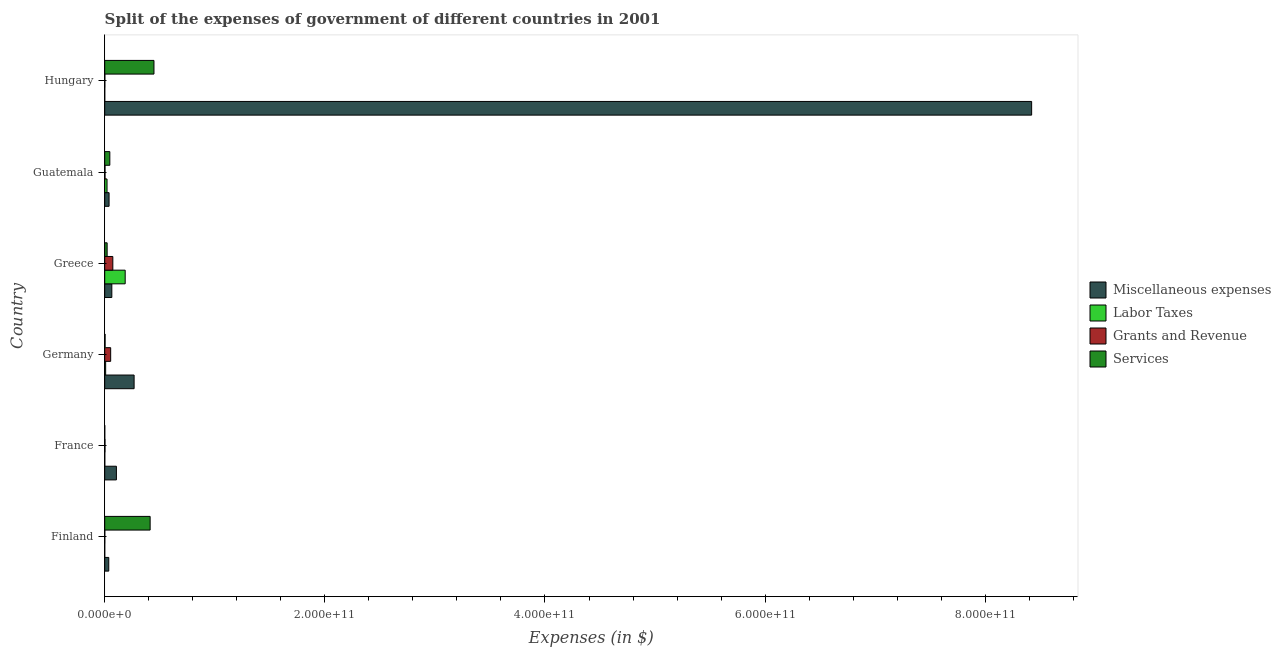How many different coloured bars are there?
Keep it short and to the point. 4. How many groups of bars are there?
Your answer should be very brief. 6. Are the number of bars per tick equal to the number of legend labels?
Provide a succinct answer. Yes. Are the number of bars on each tick of the Y-axis equal?
Offer a terse response. Yes. In how many cases, is the number of bars for a given country not equal to the number of legend labels?
Your response must be concise. 0. What is the amount spent on grants and revenue in Germany?
Provide a short and direct response. 5.41e+09. Across all countries, what is the maximum amount spent on miscellaneous expenses?
Make the answer very short. 8.42e+11. Across all countries, what is the minimum amount spent on grants and revenue?
Make the answer very short. 6.53e+07. In which country was the amount spent on miscellaneous expenses maximum?
Provide a short and direct response. Hungary. In which country was the amount spent on services minimum?
Your answer should be compact. France. What is the total amount spent on services in the graph?
Your response must be concise. 9.32e+1. What is the difference between the amount spent on miscellaneous expenses in Finland and that in France?
Ensure brevity in your answer.  -6.94e+09. What is the difference between the amount spent on services in Finland and the amount spent on grants and revenue in Germany?
Your response must be concise. 3.59e+1. What is the average amount spent on miscellaneous expenses per country?
Keep it short and to the point. 1.49e+11. What is the difference between the amount spent on labor taxes and amount spent on grants and revenue in Finland?
Provide a short and direct response. -6.29e+07. What is the ratio of the amount spent on grants and revenue in Guatemala to that in Hungary?
Keep it short and to the point. 2.46. Is the amount spent on services in Germany less than that in Greece?
Provide a short and direct response. Yes. Is the difference between the amount spent on labor taxes in France and Hungary greater than the difference between the amount spent on grants and revenue in France and Hungary?
Provide a short and direct response. No. What is the difference between the highest and the second highest amount spent on labor taxes?
Provide a succinct answer. 1.65e+1. What is the difference between the highest and the lowest amount spent on labor taxes?
Provide a succinct answer. 1.86e+1. Is the sum of the amount spent on miscellaneous expenses in Finland and France greater than the maximum amount spent on labor taxes across all countries?
Your answer should be compact. No. What does the 3rd bar from the top in Guatemala represents?
Your answer should be compact. Labor Taxes. What does the 3rd bar from the bottom in Guatemala represents?
Your answer should be very brief. Grants and Revenue. Is it the case that in every country, the sum of the amount spent on miscellaneous expenses and amount spent on labor taxes is greater than the amount spent on grants and revenue?
Your answer should be very brief. Yes. How many bars are there?
Keep it short and to the point. 24. What is the difference between two consecutive major ticks on the X-axis?
Ensure brevity in your answer.  2.00e+11. Does the graph contain grids?
Your response must be concise. No. How many legend labels are there?
Your response must be concise. 4. What is the title of the graph?
Your response must be concise. Split of the expenses of government of different countries in 2001. Does "Luxembourg" appear as one of the legend labels in the graph?
Your answer should be compact. No. What is the label or title of the X-axis?
Offer a terse response. Expenses (in $). What is the label or title of the Y-axis?
Provide a succinct answer. Country. What is the Expenses (in $) in Miscellaneous expenses in Finland?
Your response must be concise. 3.68e+09. What is the Expenses (in $) in Labor Taxes in Finland?
Provide a short and direct response. 2.40e+06. What is the Expenses (in $) of Grants and Revenue in Finland?
Your answer should be very brief. 6.53e+07. What is the Expenses (in $) in Services in Finland?
Provide a succinct answer. 4.13e+1. What is the Expenses (in $) of Miscellaneous expenses in France?
Ensure brevity in your answer.  1.06e+1. What is the Expenses (in $) of Labor Taxes in France?
Make the answer very short. 5.79e+07. What is the Expenses (in $) in Grants and Revenue in France?
Provide a short and direct response. 2.59e+08. What is the Expenses (in $) in Services in France?
Your answer should be compact. 3.23e+07. What is the Expenses (in $) in Miscellaneous expenses in Germany?
Make the answer very short. 2.67e+1. What is the Expenses (in $) of Labor Taxes in Germany?
Offer a terse response. 8.46e+08. What is the Expenses (in $) of Grants and Revenue in Germany?
Offer a terse response. 5.41e+09. What is the Expenses (in $) in Services in Germany?
Your answer should be compact. 3.44e+08. What is the Expenses (in $) of Miscellaneous expenses in Greece?
Your answer should be compact. 6.46e+09. What is the Expenses (in $) in Labor Taxes in Greece?
Keep it short and to the point. 1.86e+1. What is the Expenses (in $) in Grants and Revenue in Greece?
Provide a short and direct response. 7.37e+09. What is the Expenses (in $) of Services in Greece?
Keep it short and to the point. 2.20e+09. What is the Expenses (in $) in Miscellaneous expenses in Guatemala?
Provide a succinct answer. 3.96e+09. What is the Expenses (in $) in Labor Taxes in Guatemala?
Ensure brevity in your answer.  2.10e+09. What is the Expenses (in $) in Grants and Revenue in Guatemala?
Offer a terse response. 2.69e+08. What is the Expenses (in $) in Services in Guatemala?
Provide a short and direct response. 4.64e+09. What is the Expenses (in $) of Miscellaneous expenses in Hungary?
Keep it short and to the point. 8.42e+11. What is the Expenses (in $) of Grants and Revenue in Hungary?
Your answer should be compact. 1.09e+08. What is the Expenses (in $) of Services in Hungary?
Provide a short and direct response. 4.47e+1. Across all countries, what is the maximum Expenses (in $) in Miscellaneous expenses?
Offer a very short reply. 8.42e+11. Across all countries, what is the maximum Expenses (in $) of Labor Taxes?
Give a very brief answer. 1.86e+1. Across all countries, what is the maximum Expenses (in $) of Grants and Revenue?
Give a very brief answer. 7.37e+09. Across all countries, what is the maximum Expenses (in $) in Services?
Ensure brevity in your answer.  4.47e+1. Across all countries, what is the minimum Expenses (in $) in Miscellaneous expenses?
Make the answer very short. 3.68e+09. Across all countries, what is the minimum Expenses (in $) of Labor Taxes?
Offer a very short reply. 2.40e+06. Across all countries, what is the minimum Expenses (in $) of Grants and Revenue?
Keep it short and to the point. 6.53e+07. Across all countries, what is the minimum Expenses (in $) of Services?
Give a very brief answer. 3.23e+07. What is the total Expenses (in $) of Miscellaneous expenses in the graph?
Provide a succinct answer. 8.94e+11. What is the total Expenses (in $) in Labor Taxes in the graph?
Ensure brevity in your answer.  2.16e+1. What is the total Expenses (in $) in Grants and Revenue in the graph?
Provide a succinct answer. 1.35e+1. What is the total Expenses (in $) in Services in the graph?
Your answer should be very brief. 9.32e+1. What is the difference between the Expenses (in $) in Miscellaneous expenses in Finland and that in France?
Make the answer very short. -6.94e+09. What is the difference between the Expenses (in $) of Labor Taxes in Finland and that in France?
Offer a very short reply. -5.55e+07. What is the difference between the Expenses (in $) in Grants and Revenue in Finland and that in France?
Give a very brief answer. -1.93e+08. What is the difference between the Expenses (in $) of Services in Finland and that in France?
Your answer should be very brief. 4.12e+1. What is the difference between the Expenses (in $) of Miscellaneous expenses in Finland and that in Germany?
Provide a short and direct response. -2.30e+1. What is the difference between the Expenses (in $) of Labor Taxes in Finland and that in Germany?
Your response must be concise. -8.44e+08. What is the difference between the Expenses (in $) of Grants and Revenue in Finland and that in Germany?
Keep it short and to the point. -5.34e+09. What is the difference between the Expenses (in $) of Services in Finland and that in Germany?
Keep it short and to the point. 4.09e+1. What is the difference between the Expenses (in $) of Miscellaneous expenses in Finland and that in Greece?
Offer a very short reply. -2.79e+09. What is the difference between the Expenses (in $) of Labor Taxes in Finland and that in Greece?
Offer a very short reply. -1.86e+1. What is the difference between the Expenses (in $) in Grants and Revenue in Finland and that in Greece?
Provide a succinct answer. -7.30e+09. What is the difference between the Expenses (in $) in Services in Finland and that in Greece?
Make the answer very short. 3.91e+1. What is the difference between the Expenses (in $) of Miscellaneous expenses in Finland and that in Guatemala?
Your response must be concise. -2.79e+08. What is the difference between the Expenses (in $) of Labor Taxes in Finland and that in Guatemala?
Ensure brevity in your answer.  -2.10e+09. What is the difference between the Expenses (in $) of Grants and Revenue in Finland and that in Guatemala?
Offer a terse response. -2.03e+08. What is the difference between the Expenses (in $) of Services in Finland and that in Guatemala?
Offer a terse response. 3.66e+1. What is the difference between the Expenses (in $) of Miscellaneous expenses in Finland and that in Hungary?
Ensure brevity in your answer.  -8.38e+11. What is the difference between the Expenses (in $) of Labor Taxes in Finland and that in Hungary?
Your answer should be compact. -7.60e+06. What is the difference between the Expenses (in $) in Grants and Revenue in Finland and that in Hungary?
Keep it short and to the point. -4.39e+07. What is the difference between the Expenses (in $) in Services in Finland and that in Hungary?
Provide a succinct answer. -3.47e+09. What is the difference between the Expenses (in $) of Miscellaneous expenses in France and that in Germany?
Your response must be concise. -1.61e+1. What is the difference between the Expenses (in $) of Labor Taxes in France and that in Germany?
Keep it short and to the point. -7.88e+08. What is the difference between the Expenses (in $) of Grants and Revenue in France and that in Germany?
Your answer should be compact. -5.15e+09. What is the difference between the Expenses (in $) of Services in France and that in Germany?
Offer a terse response. -3.12e+08. What is the difference between the Expenses (in $) in Miscellaneous expenses in France and that in Greece?
Provide a succinct answer. 4.16e+09. What is the difference between the Expenses (in $) of Labor Taxes in France and that in Greece?
Offer a very short reply. -1.85e+1. What is the difference between the Expenses (in $) of Grants and Revenue in France and that in Greece?
Provide a short and direct response. -7.11e+09. What is the difference between the Expenses (in $) of Services in France and that in Greece?
Make the answer very short. -2.16e+09. What is the difference between the Expenses (in $) in Miscellaneous expenses in France and that in Guatemala?
Your answer should be compact. 6.66e+09. What is the difference between the Expenses (in $) of Labor Taxes in France and that in Guatemala?
Your answer should be very brief. -2.05e+09. What is the difference between the Expenses (in $) in Grants and Revenue in France and that in Guatemala?
Your answer should be very brief. -9.90e+06. What is the difference between the Expenses (in $) in Services in France and that in Guatemala?
Make the answer very short. -4.61e+09. What is the difference between the Expenses (in $) of Miscellaneous expenses in France and that in Hungary?
Offer a very short reply. -8.32e+11. What is the difference between the Expenses (in $) in Labor Taxes in France and that in Hungary?
Give a very brief answer. 4.79e+07. What is the difference between the Expenses (in $) in Grants and Revenue in France and that in Hungary?
Ensure brevity in your answer.  1.50e+08. What is the difference between the Expenses (in $) in Services in France and that in Hungary?
Your answer should be compact. -4.47e+1. What is the difference between the Expenses (in $) in Miscellaneous expenses in Germany and that in Greece?
Make the answer very short. 2.02e+1. What is the difference between the Expenses (in $) in Labor Taxes in Germany and that in Greece?
Your response must be concise. -1.78e+1. What is the difference between the Expenses (in $) in Grants and Revenue in Germany and that in Greece?
Provide a short and direct response. -1.96e+09. What is the difference between the Expenses (in $) of Services in Germany and that in Greece?
Your answer should be compact. -1.85e+09. What is the difference between the Expenses (in $) of Miscellaneous expenses in Germany and that in Guatemala?
Make the answer very short. 2.27e+1. What is the difference between the Expenses (in $) in Labor Taxes in Germany and that in Guatemala?
Provide a short and direct response. -1.26e+09. What is the difference between the Expenses (in $) of Grants and Revenue in Germany and that in Guatemala?
Provide a short and direct response. 5.14e+09. What is the difference between the Expenses (in $) in Services in Germany and that in Guatemala?
Your response must be concise. -4.30e+09. What is the difference between the Expenses (in $) in Miscellaneous expenses in Germany and that in Hungary?
Keep it short and to the point. -8.15e+11. What is the difference between the Expenses (in $) in Labor Taxes in Germany and that in Hungary?
Your answer should be very brief. 8.36e+08. What is the difference between the Expenses (in $) in Grants and Revenue in Germany and that in Hungary?
Provide a short and direct response. 5.30e+09. What is the difference between the Expenses (in $) in Services in Germany and that in Hungary?
Your answer should be very brief. -4.44e+1. What is the difference between the Expenses (in $) of Miscellaneous expenses in Greece and that in Guatemala?
Make the answer very short. 2.51e+09. What is the difference between the Expenses (in $) of Labor Taxes in Greece and that in Guatemala?
Provide a succinct answer. 1.65e+1. What is the difference between the Expenses (in $) in Grants and Revenue in Greece and that in Guatemala?
Your answer should be very brief. 7.10e+09. What is the difference between the Expenses (in $) of Services in Greece and that in Guatemala?
Keep it short and to the point. -2.45e+09. What is the difference between the Expenses (in $) in Miscellaneous expenses in Greece and that in Hungary?
Make the answer very short. -8.36e+11. What is the difference between the Expenses (in $) in Labor Taxes in Greece and that in Hungary?
Offer a very short reply. 1.86e+1. What is the difference between the Expenses (in $) of Grants and Revenue in Greece and that in Hungary?
Keep it short and to the point. 7.26e+09. What is the difference between the Expenses (in $) in Services in Greece and that in Hungary?
Ensure brevity in your answer.  -4.25e+1. What is the difference between the Expenses (in $) of Miscellaneous expenses in Guatemala and that in Hungary?
Make the answer very short. -8.38e+11. What is the difference between the Expenses (in $) of Labor Taxes in Guatemala and that in Hungary?
Provide a short and direct response. 2.10e+09. What is the difference between the Expenses (in $) in Grants and Revenue in Guatemala and that in Hungary?
Ensure brevity in your answer.  1.59e+08. What is the difference between the Expenses (in $) of Services in Guatemala and that in Hungary?
Your answer should be compact. -4.01e+1. What is the difference between the Expenses (in $) in Miscellaneous expenses in Finland and the Expenses (in $) in Labor Taxes in France?
Ensure brevity in your answer.  3.62e+09. What is the difference between the Expenses (in $) in Miscellaneous expenses in Finland and the Expenses (in $) in Grants and Revenue in France?
Ensure brevity in your answer.  3.42e+09. What is the difference between the Expenses (in $) in Miscellaneous expenses in Finland and the Expenses (in $) in Services in France?
Make the answer very short. 3.64e+09. What is the difference between the Expenses (in $) in Labor Taxes in Finland and the Expenses (in $) in Grants and Revenue in France?
Keep it short and to the point. -2.56e+08. What is the difference between the Expenses (in $) of Labor Taxes in Finland and the Expenses (in $) of Services in France?
Your answer should be very brief. -2.99e+07. What is the difference between the Expenses (in $) of Grants and Revenue in Finland and the Expenses (in $) of Services in France?
Make the answer very short. 3.30e+07. What is the difference between the Expenses (in $) in Miscellaneous expenses in Finland and the Expenses (in $) in Labor Taxes in Germany?
Ensure brevity in your answer.  2.83e+09. What is the difference between the Expenses (in $) in Miscellaneous expenses in Finland and the Expenses (in $) in Grants and Revenue in Germany?
Keep it short and to the point. -1.73e+09. What is the difference between the Expenses (in $) in Miscellaneous expenses in Finland and the Expenses (in $) in Services in Germany?
Your response must be concise. 3.33e+09. What is the difference between the Expenses (in $) of Labor Taxes in Finland and the Expenses (in $) of Grants and Revenue in Germany?
Keep it short and to the point. -5.41e+09. What is the difference between the Expenses (in $) in Labor Taxes in Finland and the Expenses (in $) in Services in Germany?
Offer a terse response. -3.42e+08. What is the difference between the Expenses (in $) in Grants and Revenue in Finland and the Expenses (in $) in Services in Germany?
Give a very brief answer. -2.79e+08. What is the difference between the Expenses (in $) of Miscellaneous expenses in Finland and the Expenses (in $) of Labor Taxes in Greece?
Make the answer very short. -1.49e+1. What is the difference between the Expenses (in $) in Miscellaneous expenses in Finland and the Expenses (in $) in Grants and Revenue in Greece?
Ensure brevity in your answer.  -3.69e+09. What is the difference between the Expenses (in $) in Miscellaneous expenses in Finland and the Expenses (in $) in Services in Greece?
Offer a very short reply. 1.48e+09. What is the difference between the Expenses (in $) in Labor Taxes in Finland and the Expenses (in $) in Grants and Revenue in Greece?
Give a very brief answer. -7.37e+09. What is the difference between the Expenses (in $) in Labor Taxes in Finland and the Expenses (in $) in Services in Greece?
Keep it short and to the point. -2.19e+09. What is the difference between the Expenses (in $) of Grants and Revenue in Finland and the Expenses (in $) of Services in Greece?
Your answer should be very brief. -2.13e+09. What is the difference between the Expenses (in $) of Miscellaneous expenses in Finland and the Expenses (in $) of Labor Taxes in Guatemala?
Your answer should be very brief. 1.57e+09. What is the difference between the Expenses (in $) in Miscellaneous expenses in Finland and the Expenses (in $) in Grants and Revenue in Guatemala?
Provide a succinct answer. 3.41e+09. What is the difference between the Expenses (in $) of Miscellaneous expenses in Finland and the Expenses (in $) of Services in Guatemala?
Give a very brief answer. -9.67e+08. What is the difference between the Expenses (in $) of Labor Taxes in Finland and the Expenses (in $) of Grants and Revenue in Guatemala?
Ensure brevity in your answer.  -2.66e+08. What is the difference between the Expenses (in $) of Labor Taxes in Finland and the Expenses (in $) of Services in Guatemala?
Provide a short and direct response. -4.64e+09. What is the difference between the Expenses (in $) of Grants and Revenue in Finland and the Expenses (in $) of Services in Guatemala?
Offer a very short reply. -4.58e+09. What is the difference between the Expenses (in $) of Miscellaneous expenses in Finland and the Expenses (in $) of Labor Taxes in Hungary?
Make the answer very short. 3.67e+09. What is the difference between the Expenses (in $) of Miscellaneous expenses in Finland and the Expenses (in $) of Grants and Revenue in Hungary?
Your answer should be very brief. 3.57e+09. What is the difference between the Expenses (in $) of Miscellaneous expenses in Finland and the Expenses (in $) of Services in Hungary?
Give a very brief answer. -4.11e+1. What is the difference between the Expenses (in $) in Labor Taxes in Finland and the Expenses (in $) in Grants and Revenue in Hungary?
Offer a terse response. -1.07e+08. What is the difference between the Expenses (in $) of Labor Taxes in Finland and the Expenses (in $) of Services in Hungary?
Offer a very short reply. -4.47e+1. What is the difference between the Expenses (in $) in Grants and Revenue in Finland and the Expenses (in $) in Services in Hungary?
Provide a short and direct response. -4.47e+1. What is the difference between the Expenses (in $) of Miscellaneous expenses in France and the Expenses (in $) of Labor Taxes in Germany?
Ensure brevity in your answer.  9.77e+09. What is the difference between the Expenses (in $) of Miscellaneous expenses in France and the Expenses (in $) of Grants and Revenue in Germany?
Your answer should be compact. 5.21e+09. What is the difference between the Expenses (in $) of Miscellaneous expenses in France and the Expenses (in $) of Services in Germany?
Provide a succinct answer. 1.03e+1. What is the difference between the Expenses (in $) of Labor Taxes in France and the Expenses (in $) of Grants and Revenue in Germany?
Make the answer very short. -5.35e+09. What is the difference between the Expenses (in $) in Labor Taxes in France and the Expenses (in $) in Services in Germany?
Offer a very short reply. -2.86e+08. What is the difference between the Expenses (in $) of Grants and Revenue in France and the Expenses (in $) of Services in Germany?
Ensure brevity in your answer.  -8.53e+07. What is the difference between the Expenses (in $) of Miscellaneous expenses in France and the Expenses (in $) of Labor Taxes in Greece?
Your response must be concise. -7.98e+09. What is the difference between the Expenses (in $) of Miscellaneous expenses in France and the Expenses (in $) of Grants and Revenue in Greece?
Make the answer very short. 3.25e+09. What is the difference between the Expenses (in $) in Miscellaneous expenses in France and the Expenses (in $) in Services in Greece?
Your answer should be very brief. 8.42e+09. What is the difference between the Expenses (in $) in Labor Taxes in France and the Expenses (in $) in Grants and Revenue in Greece?
Provide a succinct answer. -7.31e+09. What is the difference between the Expenses (in $) in Labor Taxes in France and the Expenses (in $) in Services in Greece?
Ensure brevity in your answer.  -2.14e+09. What is the difference between the Expenses (in $) of Grants and Revenue in France and the Expenses (in $) of Services in Greece?
Offer a very short reply. -1.94e+09. What is the difference between the Expenses (in $) in Miscellaneous expenses in France and the Expenses (in $) in Labor Taxes in Guatemala?
Keep it short and to the point. 8.51e+09. What is the difference between the Expenses (in $) of Miscellaneous expenses in France and the Expenses (in $) of Grants and Revenue in Guatemala?
Offer a very short reply. 1.04e+1. What is the difference between the Expenses (in $) of Miscellaneous expenses in France and the Expenses (in $) of Services in Guatemala?
Offer a terse response. 5.98e+09. What is the difference between the Expenses (in $) in Labor Taxes in France and the Expenses (in $) in Grants and Revenue in Guatemala?
Your answer should be very brief. -2.11e+08. What is the difference between the Expenses (in $) in Labor Taxes in France and the Expenses (in $) in Services in Guatemala?
Provide a short and direct response. -4.59e+09. What is the difference between the Expenses (in $) in Grants and Revenue in France and the Expenses (in $) in Services in Guatemala?
Offer a terse response. -4.39e+09. What is the difference between the Expenses (in $) in Miscellaneous expenses in France and the Expenses (in $) in Labor Taxes in Hungary?
Offer a very short reply. 1.06e+1. What is the difference between the Expenses (in $) of Miscellaneous expenses in France and the Expenses (in $) of Grants and Revenue in Hungary?
Provide a short and direct response. 1.05e+1. What is the difference between the Expenses (in $) of Miscellaneous expenses in France and the Expenses (in $) of Services in Hungary?
Keep it short and to the point. -3.41e+1. What is the difference between the Expenses (in $) in Labor Taxes in France and the Expenses (in $) in Grants and Revenue in Hungary?
Keep it short and to the point. -5.13e+07. What is the difference between the Expenses (in $) in Labor Taxes in France and the Expenses (in $) in Services in Hungary?
Provide a short and direct response. -4.47e+1. What is the difference between the Expenses (in $) of Grants and Revenue in France and the Expenses (in $) of Services in Hungary?
Provide a succinct answer. -4.45e+1. What is the difference between the Expenses (in $) of Miscellaneous expenses in Germany and the Expenses (in $) of Labor Taxes in Greece?
Offer a terse response. 8.10e+09. What is the difference between the Expenses (in $) of Miscellaneous expenses in Germany and the Expenses (in $) of Grants and Revenue in Greece?
Offer a very short reply. 1.93e+1. What is the difference between the Expenses (in $) in Miscellaneous expenses in Germany and the Expenses (in $) in Services in Greece?
Your response must be concise. 2.45e+1. What is the difference between the Expenses (in $) in Labor Taxes in Germany and the Expenses (in $) in Grants and Revenue in Greece?
Your response must be concise. -6.52e+09. What is the difference between the Expenses (in $) in Labor Taxes in Germany and the Expenses (in $) in Services in Greece?
Give a very brief answer. -1.35e+09. What is the difference between the Expenses (in $) in Grants and Revenue in Germany and the Expenses (in $) in Services in Greece?
Your answer should be very brief. 3.21e+09. What is the difference between the Expenses (in $) in Miscellaneous expenses in Germany and the Expenses (in $) in Labor Taxes in Guatemala?
Provide a succinct answer. 2.46e+1. What is the difference between the Expenses (in $) of Miscellaneous expenses in Germany and the Expenses (in $) of Grants and Revenue in Guatemala?
Ensure brevity in your answer.  2.64e+1. What is the difference between the Expenses (in $) of Miscellaneous expenses in Germany and the Expenses (in $) of Services in Guatemala?
Offer a very short reply. 2.21e+1. What is the difference between the Expenses (in $) of Labor Taxes in Germany and the Expenses (in $) of Grants and Revenue in Guatemala?
Keep it short and to the point. 5.77e+08. What is the difference between the Expenses (in $) of Labor Taxes in Germany and the Expenses (in $) of Services in Guatemala?
Keep it short and to the point. -3.80e+09. What is the difference between the Expenses (in $) of Grants and Revenue in Germany and the Expenses (in $) of Services in Guatemala?
Provide a succinct answer. 7.66e+08. What is the difference between the Expenses (in $) of Miscellaneous expenses in Germany and the Expenses (in $) of Labor Taxes in Hungary?
Ensure brevity in your answer.  2.67e+1. What is the difference between the Expenses (in $) in Miscellaneous expenses in Germany and the Expenses (in $) in Grants and Revenue in Hungary?
Provide a succinct answer. 2.66e+1. What is the difference between the Expenses (in $) in Miscellaneous expenses in Germany and the Expenses (in $) in Services in Hungary?
Make the answer very short. -1.80e+1. What is the difference between the Expenses (in $) in Labor Taxes in Germany and the Expenses (in $) in Grants and Revenue in Hungary?
Provide a short and direct response. 7.37e+08. What is the difference between the Expenses (in $) in Labor Taxes in Germany and the Expenses (in $) in Services in Hungary?
Offer a very short reply. -4.39e+1. What is the difference between the Expenses (in $) of Grants and Revenue in Germany and the Expenses (in $) of Services in Hungary?
Ensure brevity in your answer.  -3.93e+1. What is the difference between the Expenses (in $) of Miscellaneous expenses in Greece and the Expenses (in $) of Labor Taxes in Guatemala?
Provide a short and direct response. 4.36e+09. What is the difference between the Expenses (in $) of Miscellaneous expenses in Greece and the Expenses (in $) of Grants and Revenue in Guatemala?
Make the answer very short. 6.20e+09. What is the difference between the Expenses (in $) of Miscellaneous expenses in Greece and the Expenses (in $) of Services in Guatemala?
Give a very brief answer. 1.82e+09. What is the difference between the Expenses (in $) of Labor Taxes in Greece and the Expenses (in $) of Grants and Revenue in Guatemala?
Ensure brevity in your answer.  1.83e+1. What is the difference between the Expenses (in $) in Labor Taxes in Greece and the Expenses (in $) in Services in Guatemala?
Offer a very short reply. 1.40e+1. What is the difference between the Expenses (in $) in Grants and Revenue in Greece and the Expenses (in $) in Services in Guatemala?
Keep it short and to the point. 2.72e+09. What is the difference between the Expenses (in $) of Miscellaneous expenses in Greece and the Expenses (in $) of Labor Taxes in Hungary?
Provide a short and direct response. 6.45e+09. What is the difference between the Expenses (in $) of Miscellaneous expenses in Greece and the Expenses (in $) of Grants and Revenue in Hungary?
Keep it short and to the point. 6.35e+09. What is the difference between the Expenses (in $) of Miscellaneous expenses in Greece and the Expenses (in $) of Services in Hungary?
Provide a succinct answer. -3.83e+1. What is the difference between the Expenses (in $) in Labor Taxes in Greece and the Expenses (in $) in Grants and Revenue in Hungary?
Make the answer very short. 1.85e+1. What is the difference between the Expenses (in $) of Labor Taxes in Greece and the Expenses (in $) of Services in Hungary?
Offer a very short reply. -2.61e+1. What is the difference between the Expenses (in $) in Grants and Revenue in Greece and the Expenses (in $) in Services in Hungary?
Give a very brief answer. -3.74e+1. What is the difference between the Expenses (in $) of Miscellaneous expenses in Guatemala and the Expenses (in $) of Labor Taxes in Hungary?
Keep it short and to the point. 3.95e+09. What is the difference between the Expenses (in $) in Miscellaneous expenses in Guatemala and the Expenses (in $) in Grants and Revenue in Hungary?
Make the answer very short. 3.85e+09. What is the difference between the Expenses (in $) in Miscellaneous expenses in Guatemala and the Expenses (in $) in Services in Hungary?
Offer a terse response. -4.08e+1. What is the difference between the Expenses (in $) in Labor Taxes in Guatemala and the Expenses (in $) in Grants and Revenue in Hungary?
Keep it short and to the point. 2.00e+09. What is the difference between the Expenses (in $) of Labor Taxes in Guatemala and the Expenses (in $) of Services in Hungary?
Provide a succinct answer. -4.26e+1. What is the difference between the Expenses (in $) of Grants and Revenue in Guatemala and the Expenses (in $) of Services in Hungary?
Your answer should be very brief. -4.45e+1. What is the average Expenses (in $) in Miscellaneous expenses per country?
Ensure brevity in your answer.  1.49e+11. What is the average Expenses (in $) in Labor Taxes per country?
Offer a very short reply. 3.60e+09. What is the average Expenses (in $) in Grants and Revenue per country?
Keep it short and to the point. 2.25e+09. What is the average Expenses (in $) of Services per country?
Make the answer very short. 1.55e+1. What is the difference between the Expenses (in $) in Miscellaneous expenses and Expenses (in $) in Labor Taxes in Finland?
Your answer should be compact. 3.67e+09. What is the difference between the Expenses (in $) in Miscellaneous expenses and Expenses (in $) in Grants and Revenue in Finland?
Offer a terse response. 3.61e+09. What is the difference between the Expenses (in $) in Miscellaneous expenses and Expenses (in $) in Services in Finland?
Provide a short and direct response. -3.76e+1. What is the difference between the Expenses (in $) of Labor Taxes and Expenses (in $) of Grants and Revenue in Finland?
Your answer should be compact. -6.29e+07. What is the difference between the Expenses (in $) of Labor Taxes and Expenses (in $) of Services in Finland?
Keep it short and to the point. -4.13e+1. What is the difference between the Expenses (in $) of Grants and Revenue and Expenses (in $) of Services in Finland?
Provide a short and direct response. -4.12e+1. What is the difference between the Expenses (in $) of Miscellaneous expenses and Expenses (in $) of Labor Taxes in France?
Make the answer very short. 1.06e+1. What is the difference between the Expenses (in $) in Miscellaneous expenses and Expenses (in $) in Grants and Revenue in France?
Your response must be concise. 1.04e+1. What is the difference between the Expenses (in $) in Miscellaneous expenses and Expenses (in $) in Services in France?
Give a very brief answer. 1.06e+1. What is the difference between the Expenses (in $) in Labor Taxes and Expenses (in $) in Grants and Revenue in France?
Offer a terse response. -2.01e+08. What is the difference between the Expenses (in $) in Labor Taxes and Expenses (in $) in Services in France?
Keep it short and to the point. 2.56e+07. What is the difference between the Expenses (in $) in Grants and Revenue and Expenses (in $) in Services in France?
Provide a succinct answer. 2.26e+08. What is the difference between the Expenses (in $) in Miscellaneous expenses and Expenses (in $) in Labor Taxes in Germany?
Offer a terse response. 2.59e+1. What is the difference between the Expenses (in $) of Miscellaneous expenses and Expenses (in $) of Grants and Revenue in Germany?
Give a very brief answer. 2.13e+1. What is the difference between the Expenses (in $) in Miscellaneous expenses and Expenses (in $) in Services in Germany?
Provide a succinct answer. 2.64e+1. What is the difference between the Expenses (in $) in Labor Taxes and Expenses (in $) in Grants and Revenue in Germany?
Keep it short and to the point. -4.56e+09. What is the difference between the Expenses (in $) in Labor Taxes and Expenses (in $) in Services in Germany?
Give a very brief answer. 5.02e+08. What is the difference between the Expenses (in $) of Grants and Revenue and Expenses (in $) of Services in Germany?
Your answer should be very brief. 5.07e+09. What is the difference between the Expenses (in $) of Miscellaneous expenses and Expenses (in $) of Labor Taxes in Greece?
Your answer should be very brief. -1.21e+1. What is the difference between the Expenses (in $) of Miscellaneous expenses and Expenses (in $) of Grants and Revenue in Greece?
Offer a very short reply. -9.04e+08. What is the difference between the Expenses (in $) of Miscellaneous expenses and Expenses (in $) of Services in Greece?
Your answer should be compact. 4.27e+09. What is the difference between the Expenses (in $) of Labor Taxes and Expenses (in $) of Grants and Revenue in Greece?
Your answer should be very brief. 1.12e+1. What is the difference between the Expenses (in $) of Labor Taxes and Expenses (in $) of Services in Greece?
Your response must be concise. 1.64e+1. What is the difference between the Expenses (in $) in Grants and Revenue and Expenses (in $) in Services in Greece?
Give a very brief answer. 5.17e+09. What is the difference between the Expenses (in $) of Miscellaneous expenses and Expenses (in $) of Labor Taxes in Guatemala?
Make the answer very short. 1.85e+09. What is the difference between the Expenses (in $) in Miscellaneous expenses and Expenses (in $) in Grants and Revenue in Guatemala?
Offer a very short reply. 3.69e+09. What is the difference between the Expenses (in $) in Miscellaneous expenses and Expenses (in $) in Services in Guatemala?
Ensure brevity in your answer.  -6.88e+08. What is the difference between the Expenses (in $) in Labor Taxes and Expenses (in $) in Grants and Revenue in Guatemala?
Your answer should be very brief. 1.84e+09. What is the difference between the Expenses (in $) in Labor Taxes and Expenses (in $) in Services in Guatemala?
Give a very brief answer. -2.54e+09. What is the difference between the Expenses (in $) in Grants and Revenue and Expenses (in $) in Services in Guatemala?
Ensure brevity in your answer.  -4.38e+09. What is the difference between the Expenses (in $) in Miscellaneous expenses and Expenses (in $) in Labor Taxes in Hungary?
Offer a very short reply. 8.42e+11. What is the difference between the Expenses (in $) of Miscellaneous expenses and Expenses (in $) of Grants and Revenue in Hungary?
Offer a very short reply. 8.42e+11. What is the difference between the Expenses (in $) in Miscellaneous expenses and Expenses (in $) in Services in Hungary?
Keep it short and to the point. 7.97e+11. What is the difference between the Expenses (in $) in Labor Taxes and Expenses (in $) in Grants and Revenue in Hungary?
Your response must be concise. -9.92e+07. What is the difference between the Expenses (in $) in Labor Taxes and Expenses (in $) in Services in Hungary?
Offer a terse response. -4.47e+1. What is the difference between the Expenses (in $) in Grants and Revenue and Expenses (in $) in Services in Hungary?
Ensure brevity in your answer.  -4.46e+1. What is the ratio of the Expenses (in $) of Miscellaneous expenses in Finland to that in France?
Make the answer very short. 0.35. What is the ratio of the Expenses (in $) in Labor Taxes in Finland to that in France?
Keep it short and to the point. 0.04. What is the ratio of the Expenses (in $) of Grants and Revenue in Finland to that in France?
Your answer should be compact. 0.25. What is the ratio of the Expenses (in $) of Services in Finland to that in France?
Your answer should be compact. 1277.77. What is the ratio of the Expenses (in $) of Miscellaneous expenses in Finland to that in Germany?
Provide a short and direct response. 0.14. What is the ratio of the Expenses (in $) in Labor Taxes in Finland to that in Germany?
Offer a terse response. 0. What is the ratio of the Expenses (in $) of Grants and Revenue in Finland to that in Germany?
Offer a terse response. 0.01. What is the ratio of the Expenses (in $) in Services in Finland to that in Germany?
Keep it short and to the point. 119.98. What is the ratio of the Expenses (in $) in Miscellaneous expenses in Finland to that in Greece?
Give a very brief answer. 0.57. What is the ratio of the Expenses (in $) of Grants and Revenue in Finland to that in Greece?
Your answer should be compact. 0.01. What is the ratio of the Expenses (in $) in Services in Finland to that in Greece?
Make the answer very short. 18.79. What is the ratio of the Expenses (in $) of Miscellaneous expenses in Finland to that in Guatemala?
Make the answer very short. 0.93. What is the ratio of the Expenses (in $) of Labor Taxes in Finland to that in Guatemala?
Keep it short and to the point. 0. What is the ratio of the Expenses (in $) of Grants and Revenue in Finland to that in Guatemala?
Offer a very short reply. 0.24. What is the ratio of the Expenses (in $) in Services in Finland to that in Guatemala?
Give a very brief answer. 8.89. What is the ratio of the Expenses (in $) of Miscellaneous expenses in Finland to that in Hungary?
Your answer should be very brief. 0. What is the ratio of the Expenses (in $) of Labor Taxes in Finland to that in Hungary?
Your response must be concise. 0.24. What is the ratio of the Expenses (in $) of Grants and Revenue in Finland to that in Hungary?
Provide a short and direct response. 0.6. What is the ratio of the Expenses (in $) of Services in Finland to that in Hungary?
Offer a very short reply. 0.92. What is the ratio of the Expenses (in $) of Miscellaneous expenses in France to that in Germany?
Offer a very short reply. 0.4. What is the ratio of the Expenses (in $) of Labor Taxes in France to that in Germany?
Your answer should be compact. 0.07. What is the ratio of the Expenses (in $) of Grants and Revenue in France to that in Germany?
Your response must be concise. 0.05. What is the ratio of the Expenses (in $) of Services in France to that in Germany?
Offer a terse response. 0.09. What is the ratio of the Expenses (in $) of Miscellaneous expenses in France to that in Greece?
Provide a succinct answer. 1.64. What is the ratio of the Expenses (in $) of Labor Taxes in France to that in Greece?
Keep it short and to the point. 0. What is the ratio of the Expenses (in $) in Grants and Revenue in France to that in Greece?
Provide a succinct answer. 0.04. What is the ratio of the Expenses (in $) of Services in France to that in Greece?
Give a very brief answer. 0.01. What is the ratio of the Expenses (in $) in Miscellaneous expenses in France to that in Guatemala?
Ensure brevity in your answer.  2.68. What is the ratio of the Expenses (in $) in Labor Taxes in France to that in Guatemala?
Ensure brevity in your answer.  0.03. What is the ratio of the Expenses (in $) of Grants and Revenue in France to that in Guatemala?
Your response must be concise. 0.96. What is the ratio of the Expenses (in $) of Services in France to that in Guatemala?
Your answer should be compact. 0.01. What is the ratio of the Expenses (in $) in Miscellaneous expenses in France to that in Hungary?
Provide a succinct answer. 0.01. What is the ratio of the Expenses (in $) in Labor Taxes in France to that in Hungary?
Your response must be concise. 5.79. What is the ratio of the Expenses (in $) of Grants and Revenue in France to that in Hungary?
Provide a succinct answer. 2.37. What is the ratio of the Expenses (in $) in Services in France to that in Hungary?
Offer a terse response. 0. What is the ratio of the Expenses (in $) in Miscellaneous expenses in Germany to that in Greece?
Your answer should be very brief. 4.13. What is the ratio of the Expenses (in $) in Labor Taxes in Germany to that in Greece?
Provide a short and direct response. 0.05. What is the ratio of the Expenses (in $) in Grants and Revenue in Germany to that in Greece?
Ensure brevity in your answer.  0.73. What is the ratio of the Expenses (in $) in Services in Germany to that in Greece?
Provide a succinct answer. 0.16. What is the ratio of the Expenses (in $) of Miscellaneous expenses in Germany to that in Guatemala?
Keep it short and to the point. 6.75. What is the ratio of the Expenses (in $) of Labor Taxes in Germany to that in Guatemala?
Provide a short and direct response. 0.4. What is the ratio of the Expenses (in $) of Grants and Revenue in Germany to that in Guatemala?
Keep it short and to the point. 20.14. What is the ratio of the Expenses (in $) in Services in Germany to that in Guatemala?
Your response must be concise. 0.07. What is the ratio of the Expenses (in $) in Miscellaneous expenses in Germany to that in Hungary?
Ensure brevity in your answer.  0.03. What is the ratio of the Expenses (in $) of Labor Taxes in Germany to that in Hungary?
Keep it short and to the point. 84.6. What is the ratio of the Expenses (in $) in Grants and Revenue in Germany to that in Hungary?
Offer a very short reply. 49.54. What is the ratio of the Expenses (in $) of Services in Germany to that in Hungary?
Keep it short and to the point. 0.01. What is the ratio of the Expenses (in $) in Miscellaneous expenses in Greece to that in Guatemala?
Offer a very short reply. 1.63. What is the ratio of the Expenses (in $) in Labor Taxes in Greece to that in Guatemala?
Offer a terse response. 8.84. What is the ratio of the Expenses (in $) of Grants and Revenue in Greece to that in Guatemala?
Provide a short and direct response. 27.43. What is the ratio of the Expenses (in $) of Services in Greece to that in Guatemala?
Provide a succinct answer. 0.47. What is the ratio of the Expenses (in $) in Miscellaneous expenses in Greece to that in Hungary?
Your answer should be very brief. 0.01. What is the ratio of the Expenses (in $) of Labor Taxes in Greece to that in Hungary?
Your answer should be very brief. 1860.1. What is the ratio of the Expenses (in $) of Grants and Revenue in Greece to that in Hungary?
Provide a succinct answer. 67.47. What is the ratio of the Expenses (in $) of Services in Greece to that in Hungary?
Provide a succinct answer. 0.05. What is the ratio of the Expenses (in $) of Miscellaneous expenses in Guatemala to that in Hungary?
Give a very brief answer. 0. What is the ratio of the Expenses (in $) of Labor Taxes in Guatemala to that in Hungary?
Offer a terse response. 210.5. What is the ratio of the Expenses (in $) in Grants and Revenue in Guatemala to that in Hungary?
Offer a terse response. 2.46. What is the ratio of the Expenses (in $) in Services in Guatemala to that in Hungary?
Provide a succinct answer. 0.1. What is the difference between the highest and the second highest Expenses (in $) in Miscellaneous expenses?
Offer a terse response. 8.15e+11. What is the difference between the highest and the second highest Expenses (in $) of Labor Taxes?
Make the answer very short. 1.65e+1. What is the difference between the highest and the second highest Expenses (in $) of Grants and Revenue?
Keep it short and to the point. 1.96e+09. What is the difference between the highest and the second highest Expenses (in $) of Services?
Your response must be concise. 3.47e+09. What is the difference between the highest and the lowest Expenses (in $) of Miscellaneous expenses?
Offer a terse response. 8.38e+11. What is the difference between the highest and the lowest Expenses (in $) of Labor Taxes?
Your answer should be compact. 1.86e+1. What is the difference between the highest and the lowest Expenses (in $) of Grants and Revenue?
Keep it short and to the point. 7.30e+09. What is the difference between the highest and the lowest Expenses (in $) of Services?
Your answer should be compact. 4.47e+1. 